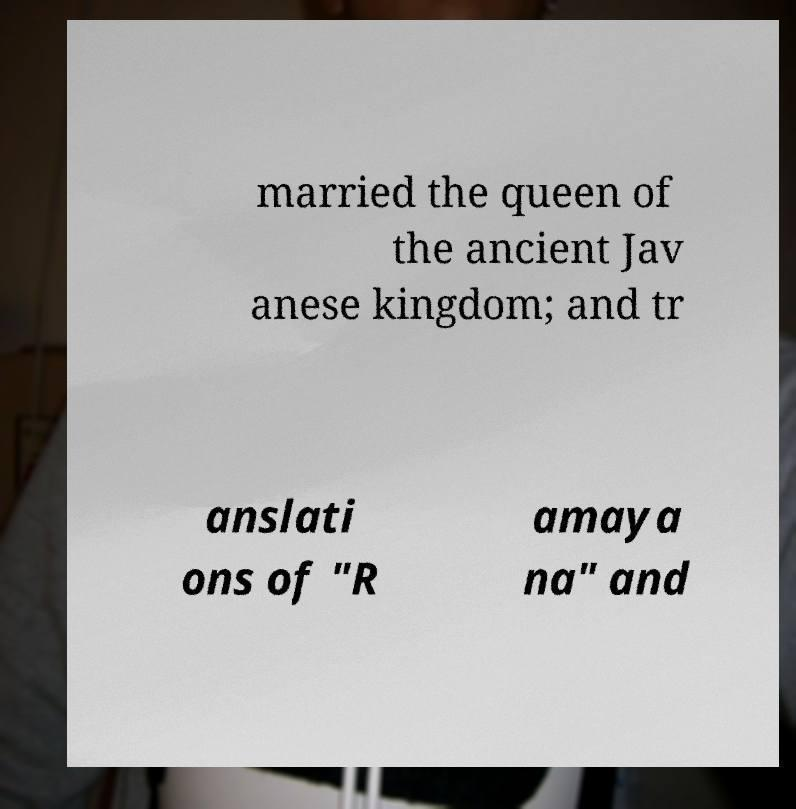For documentation purposes, I need the text within this image transcribed. Could you provide that? married the queen of the ancient Jav anese kingdom; and tr anslati ons of "R amaya na" and 